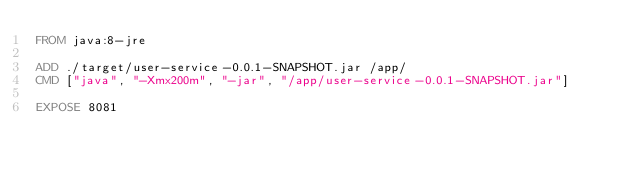<code> <loc_0><loc_0><loc_500><loc_500><_Dockerfile_>FROM java:8-jre

ADD ./target/user-service-0.0.1-SNAPSHOT.jar /app/
CMD ["java", "-Xmx200m", "-jar", "/app/user-service-0.0.1-SNAPSHOT.jar"]

EXPOSE 8081</code> 